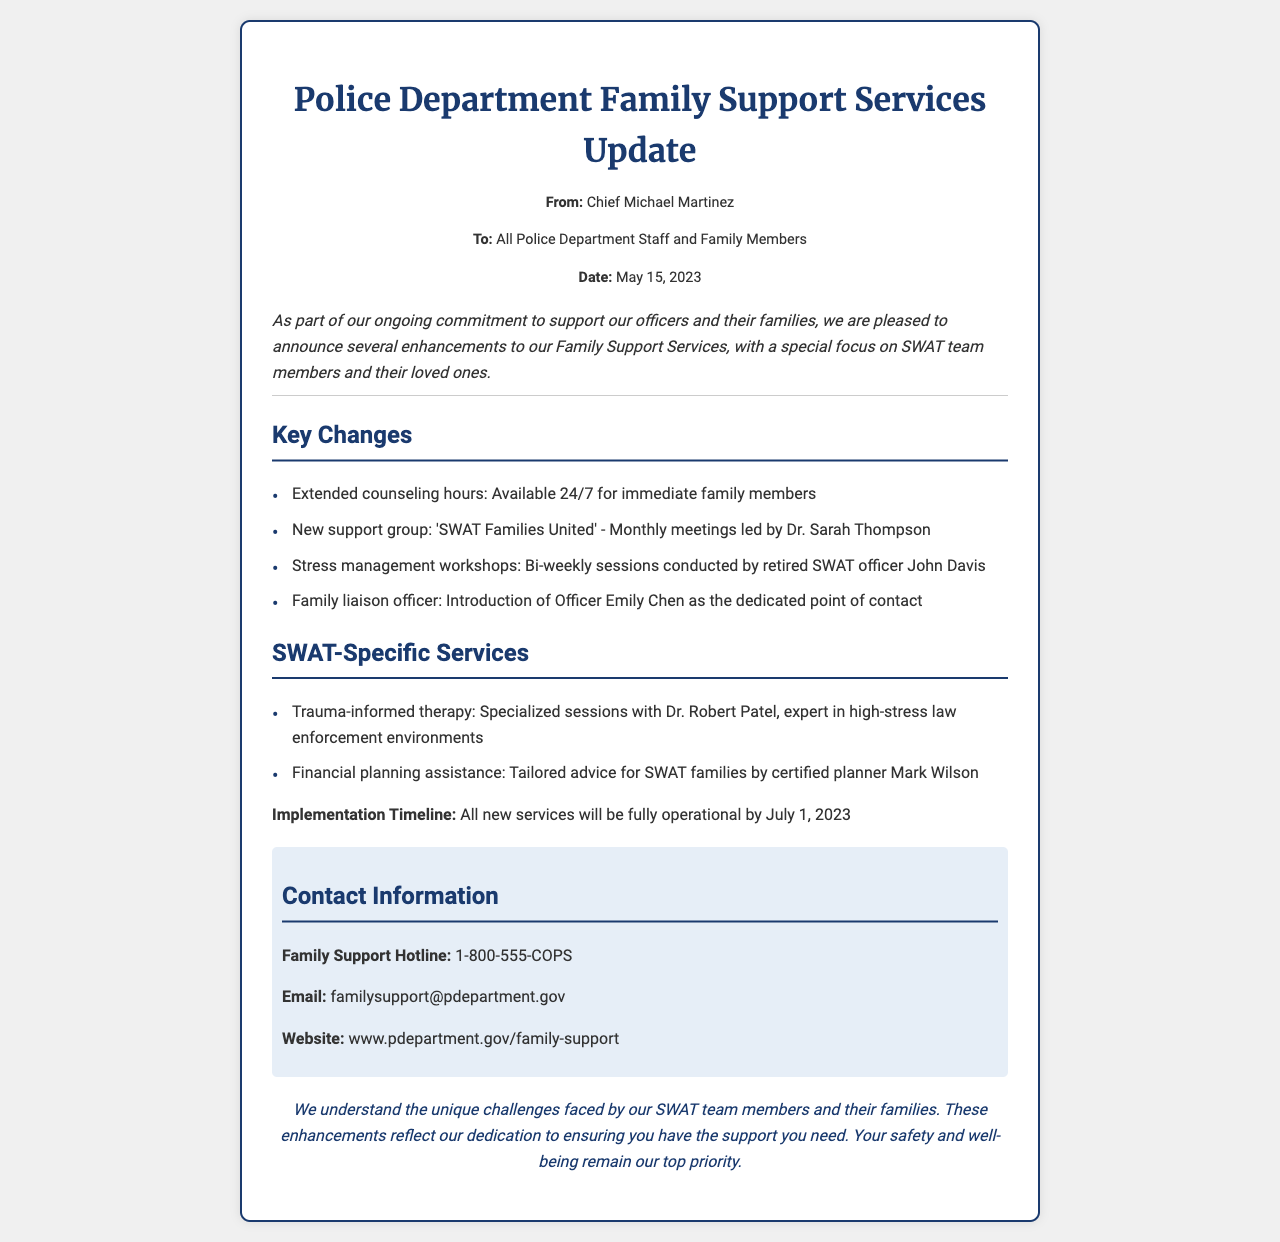What is the date of the memorandum? The date of the memorandum is explicitly mentioned in the document as May 15, 2023.
Answer: May 15, 2023 Who is the Family Liaison Officer? The document lists Officer Emily Chen as the dedicated point of contact.
Answer: Officer Emily Chen What is the name of the new support group? The support group introduced in the memorandum is named 'SWAT Families United'.
Answer: SWAT Families United How often will the stress management workshops occur? The frequency of the stress management workshops is specified as bi-weekly sessions.
Answer: Bi-weekly What service will be fully operational by July 1, 2023? The document states that all new services are set to be fully operational by the specified date.
Answer: All new services Who leads the monthly support group meetings? The name of the person leading the monthly meetings is Dr. Sarah Thompson.
Answer: Dr. Sarah Thompson What is the Family Support Hotline number? The hotline number is provided directly in the document as 1-800-555-COPS.
Answer: 1-800-555-COPS What type of therapy is offered specifically for SWAT members? The document refers to trauma-informed therapy as the specialized service offered.
Answer: Trauma-informed therapy What area of support does Mark Wilson provide assistance in? He is mentioned as a certified planner providing financial planning assistance to SWAT families.
Answer: Financial planning assistance 